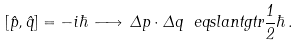Convert formula to latex. <formula><loc_0><loc_0><loc_500><loc_500>[ \hat { p } , \hat { q } ] = - i \hbar { \, } \longrightarrow \, \Delta p \cdot \Delta q \ e q s l a n t g t r \frac { 1 } { 2 } \hbar { \, } .</formula> 